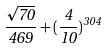<formula> <loc_0><loc_0><loc_500><loc_500>\frac { \sqrt { 7 0 } } { 4 6 9 } + ( \frac { 4 } { 1 0 } ) ^ { 3 0 4 }</formula> 